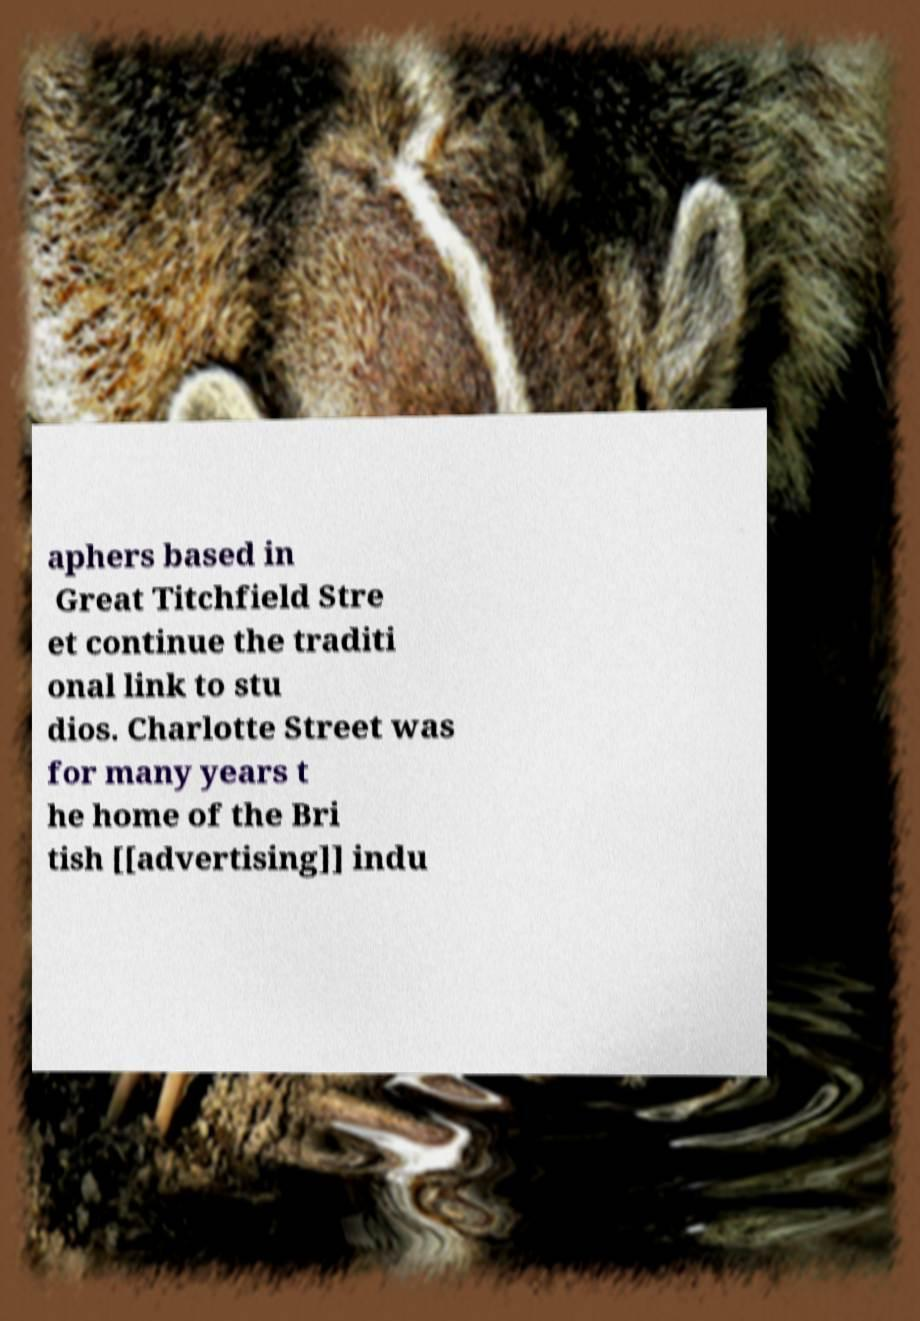Can you read and provide the text displayed in the image?This photo seems to have some interesting text. Can you extract and type it out for me? aphers based in Great Titchfield Stre et continue the traditi onal link to stu dios. Charlotte Street was for many years t he home of the Bri tish [[advertising]] indu 